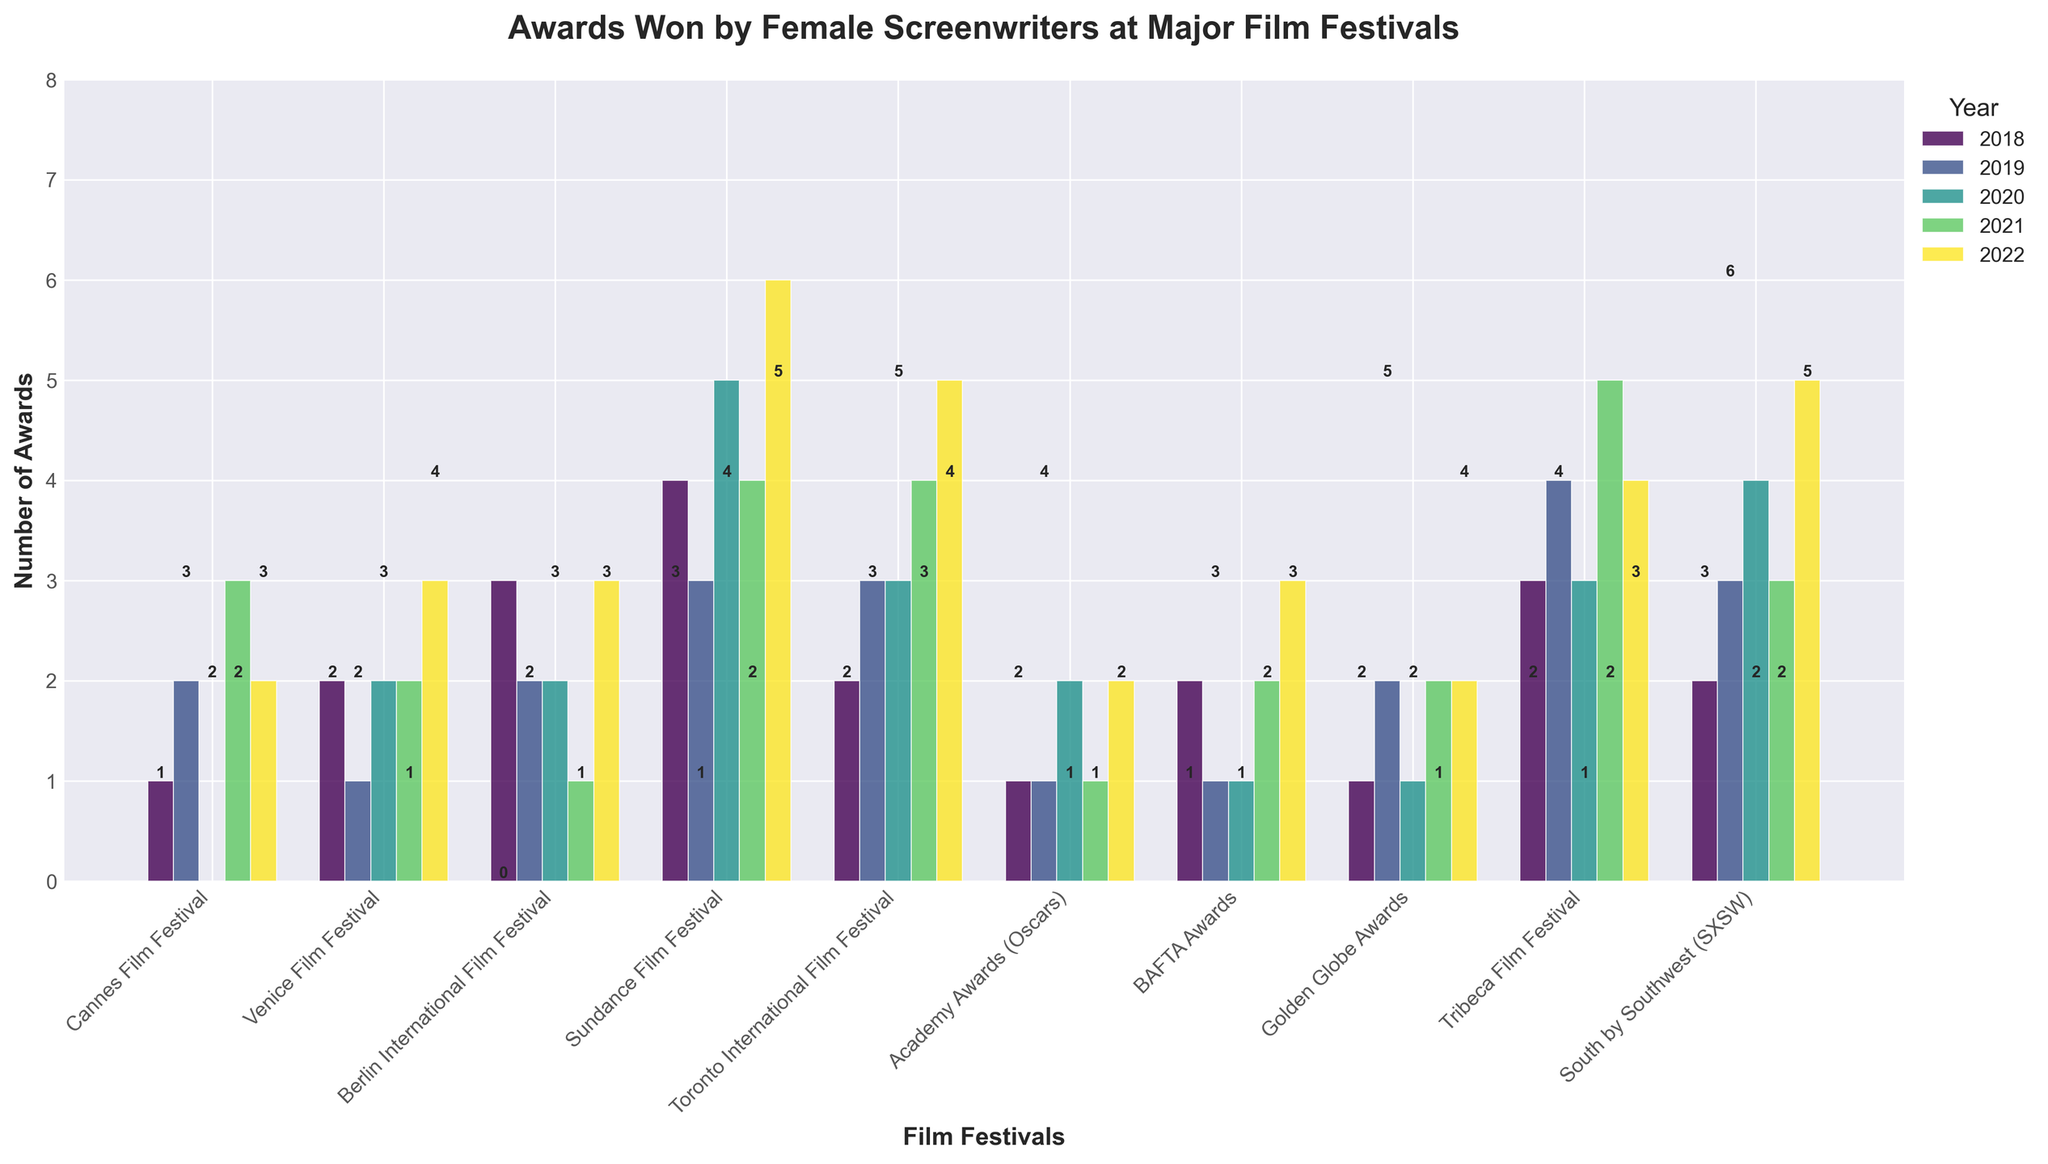Which festival had the highest number of awards in any single year? Look for the tallest bar in the entire chart. The Sundance Film Festival in 2022 has the highest bar with 6 awards.
Answer: Sundance Film Festival in 2022 Which festival awarded the most total awards over the 5 years? Summing the number of awards for each festival across all years, the Sundance Film Festival has the highest total with (4+3+5+4+6)=22.
Answer: Sundance Film Festival How many total awards were won in 2020 across all festivals? Sum all the numbers in the 2020 column: (0+2+2+5+3+2+1+1+3+4) = 23.
Answer: 23 Which years did the Berlin International Film Festival have the highest number of awards? Look at the bars for the Berlin International Film Festival to identify the highest ones. In 2018 and 2022, each had 3 awards.
Answer: 2018 and 2022 Which festival showed the most growth in awards between 2018 and 2022? Calculate the difference in the number of awards won in 2018 and 2022 for each festival and identify the largest difference. Sundance Film Festival grew from 4 to 6 (a growth of 2 awards). Additionally, South by Southwest went from 2 to 5 (a growth of 3 awards).
Answer: South by Southwest (SXSW) Which two festivals had the same number of awards in 2021? Look at the bars for 2021 and find festivals with the same height. Cannes Film Festival and Tribeca Film Festival both awarded 4.
Answer: Cannes Film Festival and Tribeca Film Festival How many awards did female screenwriters win at the Venice Film Festival in 2019 compared to 2022? For Venice Film Festival, compare the numbers for 2019 and 2022 (1 in 2019 and 3 in 2022).
Answer: 1 in 2019 and 3 in 2022 Which year did the BAFTA Awards show a decrease in awards compared to the previous year? Look at the heights of the BAFTA Awards bars from year to year. From 2018 to 2019, the number decreased from 2 to 1.
Answer: 2019 What is the average number of awards won at the Golden Globe Awards over the 5 years? Sum the numbers for the Golden Globe Awards and divide by 5: (1+2+1+2+2)=8, 8/5=1.6.
Answer: 1.6 